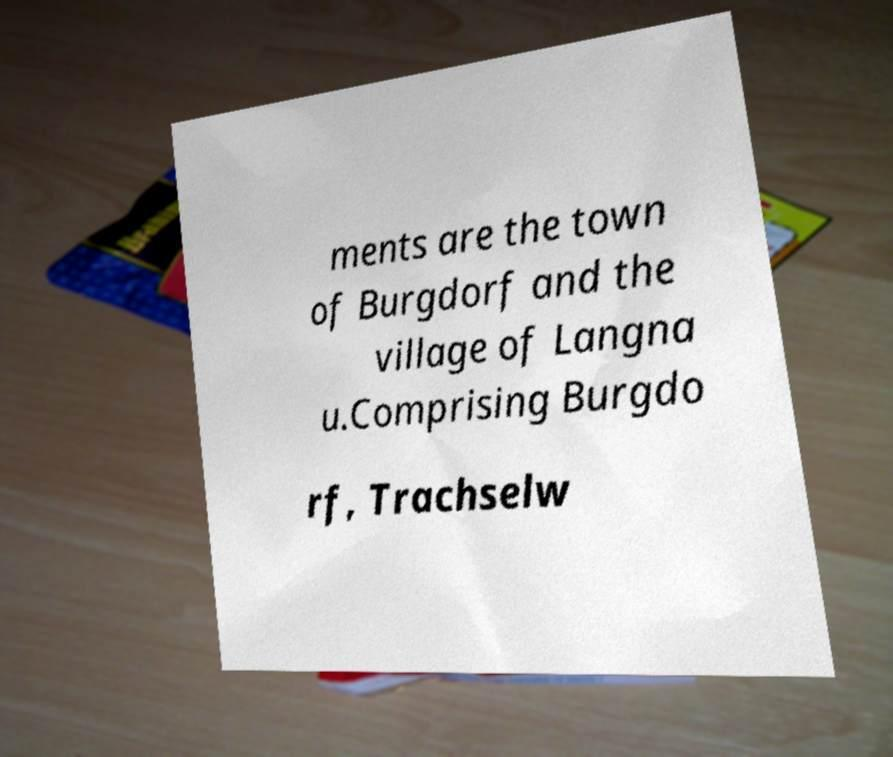Please identify and transcribe the text found in this image. ments are the town of Burgdorf and the village of Langna u.Comprising Burgdo rf, Trachselw 